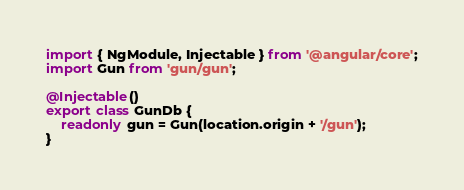<code> <loc_0><loc_0><loc_500><loc_500><_TypeScript_>import { NgModule, Injectable } from '@angular/core';
import Gun from 'gun/gun';

@Injectable()
export class GunDb {
    readonly gun = Gun(location.origin + '/gun');
}
</code> 